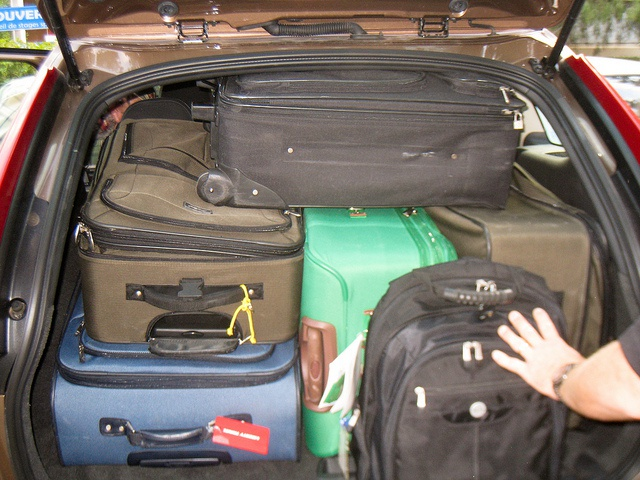Describe the objects in this image and their specific colors. I can see suitcase in olive, gray, and black tones, suitcase in olive, gray, and black tones, backpack in olive, gray, and black tones, suitcase in olive, gray, darkgray, and black tones, and suitcase in olive, aquamarine, and ivory tones in this image. 